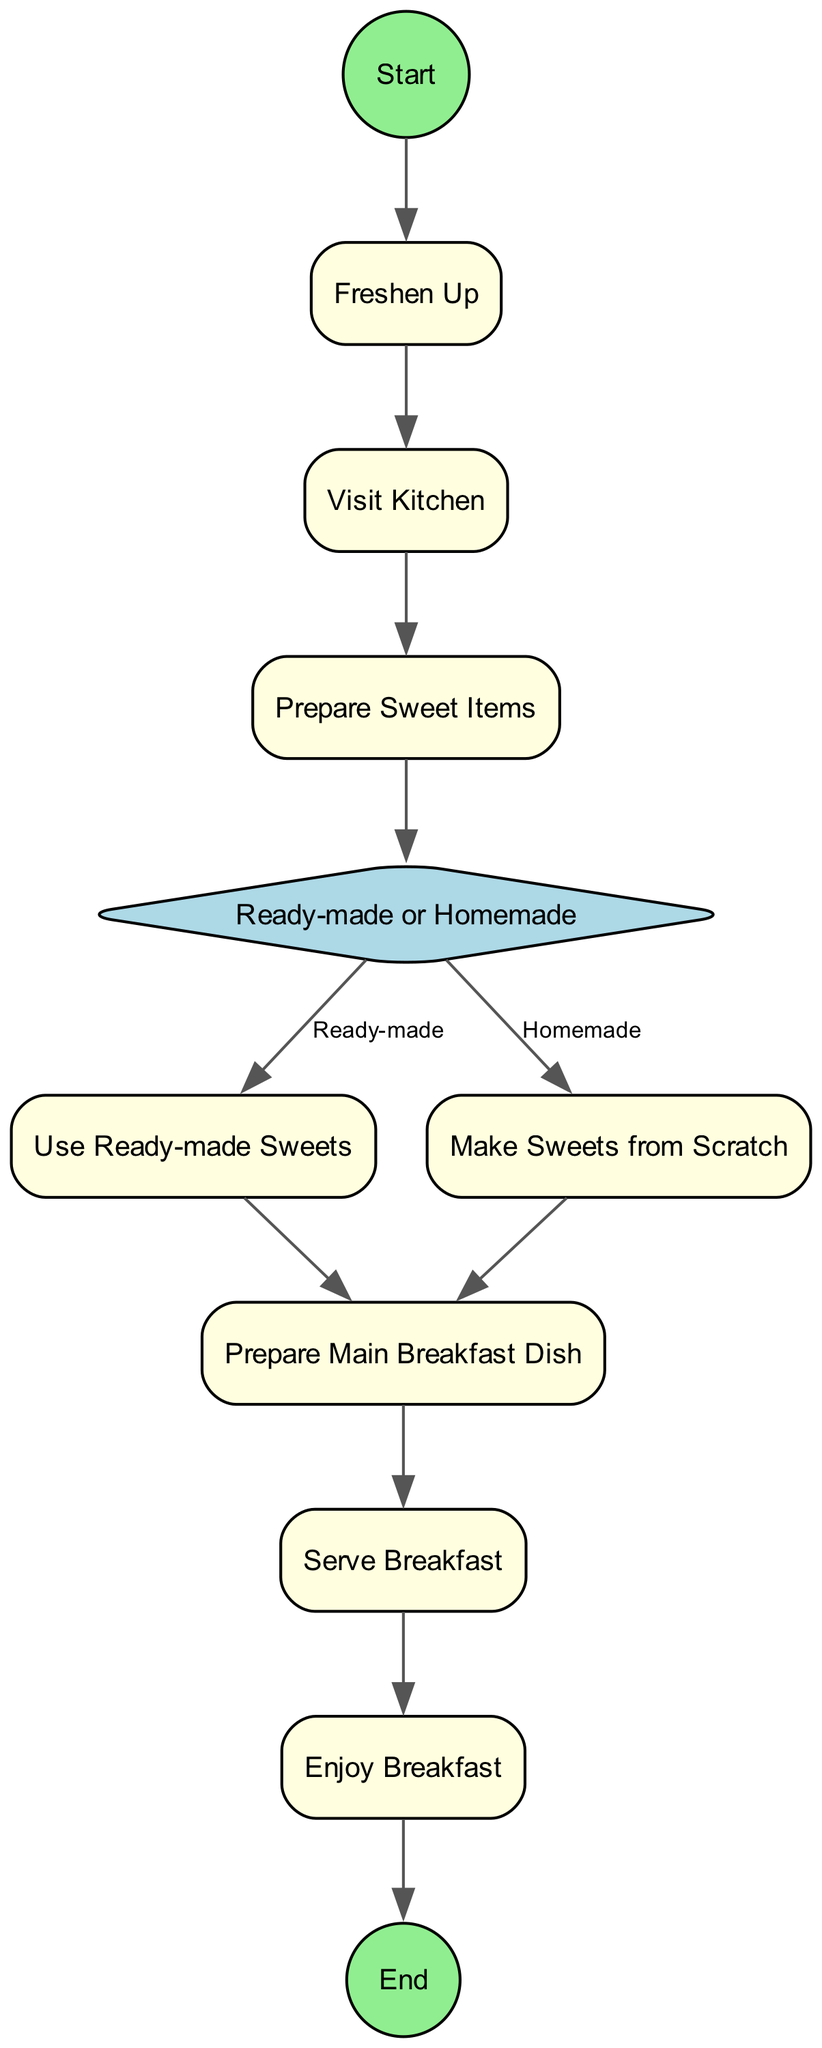What is the first action in the morning routine? The first action listed in the diagram is triggered immediately after starting the morning routine, which is "Freshen Up."
Answer: Freshen Up How many actions are present in the diagram? Upon examining the nodes classified as actions, there are a total of six action nodes before any decision-making occurs, namely: Freshen Up, Visit Kitchen, Prepare Sweet Items, Use Ready-made Sweets, Make Sweets from Scratch, and Prepare Main Breakfast Dish.
Answer: Six What decision is made during the breakfast preparation? The decision made during the breakfast preparation is between using ready-made sweets or making sweets from scratch. This represents the two possible paths the activity can take at that point.
Answer: Ready-made or Homemade Which action comes after "Prepare Sweet Items"? After completing the action of preparing sweet items, the next step is the decision node, which requires evaluating whether to use ready-made or homemade sweets.
Answer: Ready-made or Homemade What does the food lover do after enjoying breakfast? After enjoying breakfast, the final activity in the morning routine is to conclude the activities by reaching the End node.
Answer: End How many edges lead from the decision node? The decision node has two outgoing edges, indicating two outcomes: one for ready-made sweets and another for homemade sweets.
Answer: Two What is the last action before the morning routine ends? Before the morning routine concludes, the last actionable step taken by the food lover is to "Enjoy Breakfast," which includes consuming all the prepared items.
Answer: Enjoy Breakfast Which sweet items are mentioned in the morning routine? The mentioned sweet items in the preparation are Mishti Doi, Chomchom, and Rasgulla; these are traditional sweets that hold cultural significance.
Answer: Mishti Doi, Chomchom, Rasgulla What prepares the main breakfast dish? The action "Prepare Main Breakfast Dish" is the step dedicated to preparing other traditional breakfast items, which follows the decision made regarding sweets.
Answer: Prepare Main Breakfast Dish 